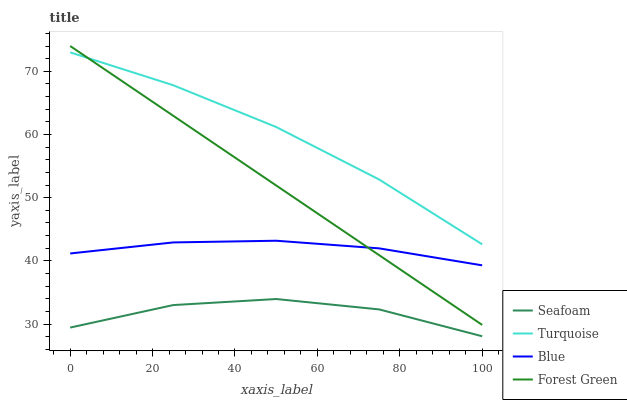Does Seafoam have the minimum area under the curve?
Answer yes or no. Yes. Does Turquoise have the maximum area under the curve?
Answer yes or no. Yes. Does Turquoise have the minimum area under the curve?
Answer yes or no. No. Does Seafoam have the maximum area under the curve?
Answer yes or no. No. Is Forest Green the smoothest?
Answer yes or no. Yes. Is Seafoam the roughest?
Answer yes or no. Yes. Is Turquoise the smoothest?
Answer yes or no. No. Is Turquoise the roughest?
Answer yes or no. No. Does Seafoam have the lowest value?
Answer yes or no. Yes. Does Turquoise have the lowest value?
Answer yes or no. No. Does Forest Green have the highest value?
Answer yes or no. Yes. Does Turquoise have the highest value?
Answer yes or no. No. Is Seafoam less than Forest Green?
Answer yes or no. Yes. Is Forest Green greater than Seafoam?
Answer yes or no. Yes. Does Forest Green intersect Turquoise?
Answer yes or no. Yes. Is Forest Green less than Turquoise?
Answer yes or no. No. Is Forest Green greater than Turquoise?
Answer yes or no. No. Does Seafoam intersect Forest Green?
Answer yes or no. No. 